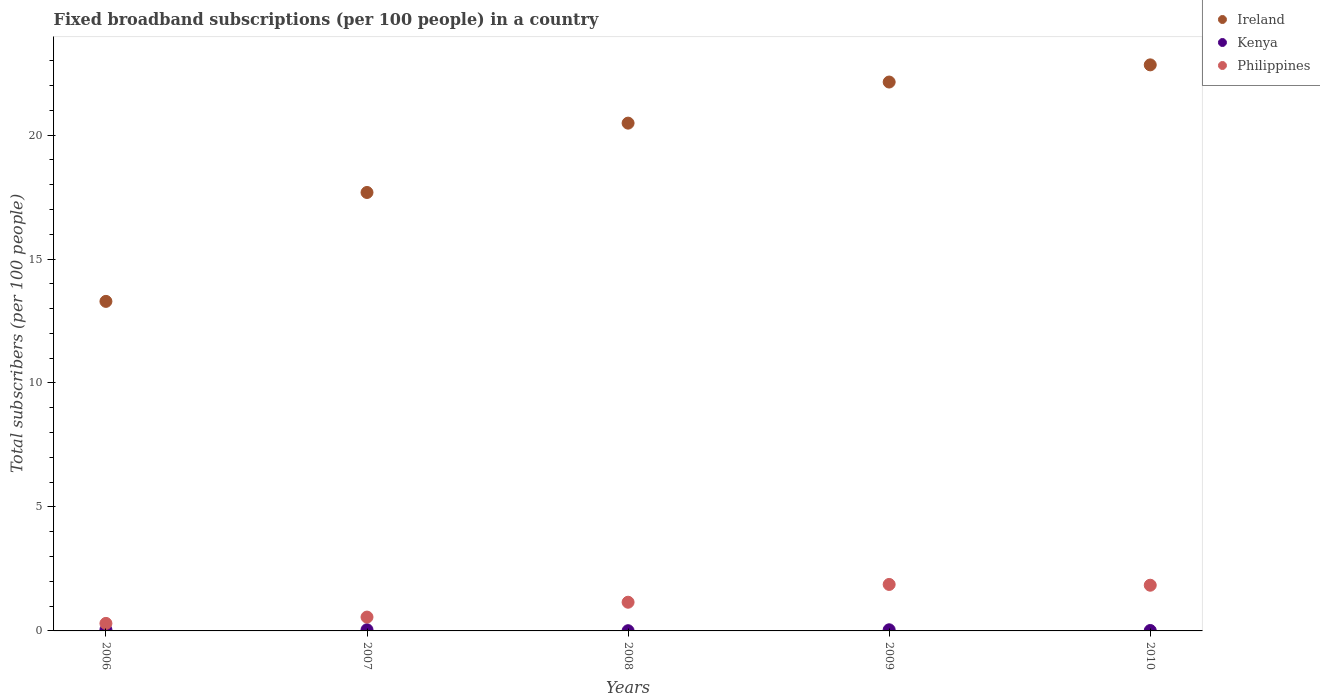How many different coloured dotlines are there?
Your answer should be compact. 3. Is the number of dotlines equal to the number of legend labels?
Provide a succinct answer. Yes. What is the number of broadband subscriptions in Philippines in 2010?
Offer a terse response. 1.84. Across all years, what is the maximum number of broadband subscriptions in Kenya?
Provide a succinct answer. 0.05. Across all years, what is the minimum number of broadband subscriptions in Ireland?
Offer a terse response. 13.29. What is the total number of broadband subscriptions in Kenya in the graph?
Ensure brevity in your answer.  0.17. What is the difference between the number of broadband subscriptions in Ireland in 2006 and that in 2007?
Your answer should be very brief. -4.39. What is the difference between the number of broadband subscriptions in Philippines in 2006 and the number of broadband subscriptions in Kenya in 2007?
Give a very brief answer. 0.26. What is the average number of broadband subscriptions in Kenya per year?
Offer a terse response. 0.03. In the year 2007, what is the difference between the number of broadband subscriptions in Ireland and number of broadband subscriptions in Philippines?
Your answer should be compact. 17.13. In how many years, is the number of broadband subscriptions in Ireland greater than 15?
Offer a very short reply. 4. What is the ratio of the number of broadband subscriptions in Philippines in 2008 to that in 2009?
Give a very brief answer. 0.62. Is the difference between the number of broadband subscriptions in Ireland in 2006 and 2008 greater than the difference between the number of broadband subscriptions in Philippines in 2006 and 2008?
Keep it short and to the point. No. What is the difference between the highest and the second highest number of broadband subscriptions in Kenya?
Offer a terse response. 0. What is the difference between the highest and the lowest number of broadband subscriptions in Ireland?
Your response must be concise. 9.54. In how many years, is the number of broadband subscriptions in Ireland greater than the average number of broadband subscriptions in Ireland taken over all years?
Offer a very short reply. 3. Does the number of broadband subscriptions in Ireland monotonically increase over the years?
Your answer should be compact. Yes. Is the number of broadband subscriptions in Kenya strictly less than the number of broadband subscriptions in Ireland over the years?
Your answer should be very brief. Yes. How many dotlines are there?
Your answer should be compact. 3. Does the graph contain any zero values?
Offer a very short reply. No. How many legend labels are there?
Offer a terse response. 3. What is the title of the graph?
Make the answer very short. Fixed broadband subscriptions (per 100 people) in a country. What is the label or title of the X-axis?
Your answer should be very brief. Years. What is the label or title of the Y-axis?
Provide a succinct answer. Total subscribers (per 100 people). What is the Total subscribers (per 100 people) of Ireland in 2006?
Give a very brief answer. 13.29. What is the Total subscribers (per 100 people) in Kenya in 2006?
Provide a succinct answer. 0.05. What is the Total subscribers (per 100 people) of Philippines in 2006?
Give a very brief answer. 0.3. What is the Total subscribers (per 100 people) of Ireland in 2007?
Provide a short and direct response. 17.68. What is the Total subscribers (per 100 people) of Kenya in 2007?
Your response must be concise. 0.05. What is the Total subscribers (per 100 people) in Philippines in 2007?
Give a very brief answer. 0.56. What is the Total subscribers (per 100 people) in Ireland in 2008?
Keep it short and to the point. 20.48. What is the Total subscribers (per 100 people) in Kenya in 2008?
Keep it short and to the point. 0.01. What is the Total subscribers (per 100 people) of Philippines in 2008?
Offer a very short reply. 1.16. What is the Total subscribers (per 100 people) in Ireland in 2009?
Ensure brevity in your answer.  22.14. What is the Total subscribers (per 100 people) in Kenya in 2009?
Provide a short and direct response. 0.05. What is the Total subscribers (per 100 people) of Philippines in 2009?
Ensure brevity in your answer.  1.87. What is the Total subscribers (per 100 people) of Ireland in 2010?
Make the answer very short. 22.83. What is the Total subscribers (per 100 people) of Kenya in 2010?
Offer a very short reply. 0.02. What is the Total subscribers (per 100 people) in Philippines in 2010?
Keep it short and to the point. 1.84. Across all years, what is the maximum Total subscribers (per 100 people) of Ireland?
Offer a terse response. 22.83. Across all years, what is the maximum Total subscribers (per 100 people) of Kenya?
Provide a short and direct response. 0.05. Across all years, what is the maximum Total subscribers (per 100 people) of Philippines?
Offer a very short reply. 1.87. Across all years, what is the minimum Total subscribers (per 100 people) of Ireland?
Provide a short and direct response. 13.29. Across all years, what is the minimum Total subscribers (per 100 people) of Kenya?
Keep it short and to the point. 0.01. Across all years, what is the minimum Total subscribers (per 100 people) of Philippines?
Offer a very short reply. 0.3. What is the total Total subscribers (per 100 people) of Ireland in the graph?
Make the answer very short. 96.42. What is the total Total subscribers (per 100 people) of Kenya in the graph?
Offer a very short reply. 0.17. What is the total Total subscribers (per 100 people) of Philippines in the graph?
Provide a short and direct response. 5.74. What is the difference between the Total subscribers (per 100 people) in Ireland in 2006 and that in 2007?
Your answer should be compact. -4.39. What is the difference between the Total subscribers (per 100 people) of Kenya in 2006 and that in 2007?
Provide a succinct answer. 0. What is the difference between the Total subscribers (per 100 people) of Philippines in 2006 and that in 2007?
Offer a terse response. -0.25. What is the difference between the Total subscribers (per 100 people) in Ireland in 2006 and that in 2008?
Your response must be concise. -7.19. What is the difference between the Total subscribers (per 100 people) in Kenya in 2006 and that in 2008?
Offer a very short reply. 0.04. What is the difference between the Total subscribers (per 100 people) in Philippines in 2006 and that in 2008?
Ensure brevity in your answer.  -0.85. What is the difference between the Total subscribers (per 100 people) in Ireland in 2006 and that in 2009?
Offer a very short reply. -8.85. What is the difference between the Total subscribers (per 100 people) in Kenya in 2006 and that in 2009?
Provide a short and direct response. 0. What is the difference between the Total subscribers (per 100 people) of Philippines in 2006 and that in 2009?
Your answer should be very brief. -1.57. What is the difference between the Total subscribers (per 100 people) of Ireland in 2006 and that in 2010?
Your answer should be very brief. -9.54. What is the difference between the Total subscribers (per 100 people) of Kenya in 2006 and that in 2010?
Your answer should be very brief. 0.03. What is the difference between the Total subscribers (per 100 people) of Philippines in 2006 and that in 2010?
Your answer should be very brief. -1.54. What is the difference between the Total subscribers (per 100 people) in Ireland in 2007 and that in 2008?
Your response must be concise. -2.8. What is the difference between the Total subscribers (per 100 people) in Kenya in 2007 and that in 2008?
Make the answer very short. 0.04. What is the difference between the Total subscribers (per 100 people) in Philippines in 2007 and that in 2008?
Offer a very short reply. -0.6. What is the difference between the Total subscribers (per 100 people) of Ireland in 2007 and that in 2009?
Give a very brief answer. -4.45. What is the difference between the Total subscribers (per 100 people) in Kenya in 2007 and that in 2009?
Your answer should be very brief. 0. What is the difference between the Total subscribers (per 100 people) of Philippines in 2007 and that in 2009?
Your answer should be very brief. -1.32. What is the difference between the Total subscribers (per 100 people) in Ireland in 2007 and that in 2010?
Your answer should be compact. -5.15. What is the difference between the Total subscribers (per 100 people) in Kenya in 2007 and that in 2010?
Provide a short and direct response. 0.03. What is the difference between the Total subscribers (per 100 people) of Philippines in 2007 and that in 2010?
Give a very brief answer. -1.28. What is the difference between the Total subscribers (per 100 people) in Ireland in 2008 and that in 2009?
Provide a succinct answer. -1.66. What is the difference between the Total subscribers (per 100 people) in Kenya in 2008 and that in 2009?
Keep it short and to the point. -0.04. What is the difference between the Total subscribers (per 100 people) in Philippines in 2008 and that in 2009?
Keep it short and to the point. -0.72. What is the difference between the Total subscribers (per 100 people) in Ireland in 2008 and that in 2010?
Make the answer very short. -2.35. What is the difference between the Total subscribers (per 100 people) in Kenya in 2008 and that in 2010?
Your answer should be very brief. -0.01. What is the difference between the Total subscribers (per 100 people) of Philippines in 2008 and that in 2010?
Offer a very short reply. -0.69. What is the difference between the Total subscribers (per 100 people) in Ireland in 2009 and that in 2010?
Keep it short and to the point. -0.69. What is the difference between the Total subscribers (per 100 people) in Kenya in 2009 and that in 2010?
Offer a terse response. 0.03. What is the difference between the Total subscribers (per 100 people) in Philippines in 2009 and that in 2010?
Offer a very short reply. 0.03. What is the difference between the Total subscribers (per 100 people) of Ireland in 2006 and the Total subscribers (per 100 people) of Kenya in 2007?
Offer a terse response. 13.24. What is the difference between the Total subscribers (per 100 people) of Ireland in 2006 and the Total subscribers (per 100 people) of Philippines in 2007?
Provide a succinct answer. 12.73. What is the difference between the Total subscribers (per 100 people) in Kenya in 2006 and the Total subscribers (per 100 people) in Philippines in 2007?
Offer a terse response. -0.51. What is the difference between the Total subscribers (per 100 people) in Ireland in 2006 and the Total subscribers (per 100 people) in Kenya in 2008?
Your answer should be compact. 13.28. What is the difference between the Total subscribers (per 100 people) of Ireland in 2006 and the Total subscribers (per 100 people) of Philippines in 2008?
Ensure brevity in your answer.  12.13. What is the difference between the Total subscribers (per 100 people) in Kenya in 2006 and the Total subscribers (per 100 people) in Philippines in 2008?
Your answer should be very brief. -1.11. What is the difference between the Total subscribers (per 100 people) in Ireland in 2006 and the Total subscribers (per 100 people) in Kenya in 2009?
Keep it short and to the point. 13.25. What is the difference between the Total subscribers (per 100 people) of Ireland in 2006 and the Total subscribers (per 100 people) of Philippines in 2009?
Your response must be concise. 11.42. What is the difference between the Total subscribers (per 100 people) of Kenya in 2006 and the Total subscribers (per 100 people) of Philippines in 2009?
Make the answer very short. -1.83. What is the difference between the Total subscribers (per 100 people) in Ireland in 2006 and the Total subscribers (per 100 people) in Kenya in 2010?
Make the answer very short. 13.27. What is the difference between the Total subscribers (per 100 people) of Ireland in 2006 and the Total subscribers (per 100 people) of Philippines in 2010?
Keep it short and to the point. 11.45. What is the difference between the Total subscribers (per 100 people) of Kenya in 2006 and the Total subscribers (per 100 people) of Philippines in 2010?
Make the answer very short. -1.79. What is the difference between the Total subscribers (per 100 people) in Ireland in 2007 and the Total subscribers (per 100 people) in Kenya in 2008?
Your response must be concise. 17.68. What is the difference between the Total subscribers (per 100 people) in Ireland in 2007 and the Total subscribers (per 100 people) in Philippines in 2008?
Give a very brief answer. 16.53. What is the difference between the Total subscribers (per 100 people) of Kenya in 2007 and the Total subscribers (per 100 people) of Philippines in 2008?
Provide a short and direct response. -1.11. What is the difference between the Total subscribers (per 100 people) in Ireland in 2007 and the Total subscribers (per 100 people) in Kenya in 2009?
Ensure brevity in your answer.  17.64. What is the difference between the Total subscribers (per 100 people) of Ireland in 2007 and the Total subscribers (per 100 people) of Philippines in 2009?
Your response must be concise. 15.81. What is the difference between the Total subscribers (per 100 people) of Kenya in 2007 and the Total subscribers (per 100 people) of Philippines in 2009?
Offer a very short reply. -1.83. What is the difference between the Total subscribers (per 100 people) in Ireland in 2007 and the Total subscribers (per 100 people) in Kenya in 2010?
Offer a terse response. 17.67. What is the difference between the Total subscribers (per 100 people) of Ireland in 2007 and the Total subscribers (per 100 people) of Philippines in 2010?
Offer a terse response. 15.84. What is the difference between the Total subscribers (per 100 people) in Kenya in 2007 and the Total subscribers (per 100 people) in Philippines in 2010?
Offer a terse response. -1.8. What is the difference between the Total subscribers (per 100 people) in Ireland in 2008 and the Total subscribers (per 100 people) in Kenya in 2009?
Provide a short and direct response. 20.43. What is the difference between the Total subscribers (per 100 people) in Ireland in 2008 and the Total subscribers (per 100 people) in Philippines in 2009?
Provide a short and direct response. 18.61. What is the difference between the Total subscribers (per 100 people) in Kenya in 2008 and the Total subscribers (per 100 people) in Philippines in 2009?
Your answer should be compact. -1.87. What is the difference between the Total subscribers (per 100 people) of Ireland in 2008 and the Total subscribers (per 100 people) of Kenya in 2010?
Ensure brevity in your answer.  20.46. What is the difference between the Total subscribers (per 100 people) in Ireland in 2008 and the Total subscribers (per 100 people) in Philippines in 2010?
Provide a succinct answer. 18.64. What is the difference between the Total subscribers (per 100 people) of Kenya in 2008 and the Total subscribers (per 100 people) of Philippines in 2010?
Give a very brief answer. -1.83. What is the difference between the Total subscribers (per 100 people) in Ireland in 2009 and the Total subscribers (per 100 people) in Kenya in 2010?
Make the answer very short. 22.12. What is the difference between the Total subscribers (per 100 people) of Ireland in 2009 and the Total subscribers (per 100 people) of Philippines in 2010?
Make the answer very short. 20.29. What is the difference between the Total subscribers (per 100 people) of Kenya in 2009 and the Total subscribers (per 100 people) of Philippines in 2010?
Your response must be concise. -1.8. What is the average Total subscribers (per 100 people) in Ireland per year?
Your answer should be very brief. 19.28. What is the average Total subscribers (per 100 people) in Kenya per year?
Your response must be concise. 0.03. What is the average Total subscribers (per 100 people) of Philippines per year?
Your answer should be compact. 1.15. In the year 2006, what is the difference between the Total subscribers (per 100 people) in Ireland and Total subscribers (per 100 people) in Kenya?
Keep it short and to the point. 13.24. In the year 2006, what is the difference between the Total subscribers (per 100 people) of Ireland and Total subscribers (per 100 people) of Philippines?
Your response must be concise. 12.99. In the year 2006, what is the difference between the Total subscribers (per 100 people) of Kenya and Total subscribers (per 100 people) of Philippines?
Give a very brief answer. -0.26. In the year 2007, what is the difference between the Total subscribers (per 100 people) in Ireland and Total subscribers (per 100 people) in Kenya?
Keep it short and to the point. 17.64. In the year 2007, what is the difference between the Total subscribers (per 100 people) of Ireland and Total subscribers (per 100 people) of Philippines?
Provide a short and direct response. 17.13. In the year 2007, what is the difference between the Total subscribers (per 100 people) of Kenya and Total subscribers (per 100 people) of Philippines?
Keep it short and to the point. -0.51. In the year 2008, what is the difference between the Total subscribers (per 100 people) in Ireland and Total subscribers (per 100 people) in Kenya?
Provide a short and direct response. 20.47. In the year 2008, what is the difference between the Total subscribers (per 100 people) of Ireland and Total subscribers (per 100 people) of Philippines?
Provide a succinct answer. 19.32. In the year 2008, what is the difference between the Total subscribers (per 100 people) of Kenya and Total subscribers (per 100 people) of Philippines?
Give a very brief answer. -1.15. In the year 2009, what is the difference between the Total subscribers (per 100 people) of Ireland and Total subscribers (per 100 people) of Kenya?
Give a very brief answer. 22.09. In the year 2009, what is the difference between the Total subscribers (per 100 people) in Ireland and Total subscribers (per 100 people) in Philippines?
Provide a succinct answer. 20.26. In the year 2009, what is the difference between the Total subscribers (per 100 people) in Kenya and Total subscribers (per 100 people) in Philippines?
Provide a succinct answer. -1.83. In the year 2010, what is the difference between the Total subscribers (per 100 people) in Ireland and Total subscribers (per 100 people) in Kenya?
Offer a terse response. 22.81. In the year 2010, what is the difference between the Total subscribers (per 100 people) in Ireland and Total subscribers (per 100 people) in Philippines?
Offer a terse response. 20.99. In the year 2010, what is the difference between the Total subscribers (per 100 people) of Kenya and Total subscribers (per 100 people) of Philippines?
Your answer should be compact. -1.83. What is the ratio of the Total subscribers (per 100 people) in Ireland in 2006 to that in 2007?
Your answer should be compact. 0.75. What is the ratio of the Total subscribers (per 100 people) in Kenya in 2006 to that in 2007?
Your answer should be very brief. 1.03. What is the ratio of the Total subscribers (per 100 people) in Philippines in 2006 to that in 2007?
Provide a short and direct response. 0.54. What is the ratio of the Total subscribers (per 100 people) in Ireland in 2006 to that in 2008?
Offer a very short reply. 0.65. What is the ratio of the Total subscribers (per 100 people) in Kenya in 2006 to that in 2008?
Your response must be concise. 5.7. What is the ratio of the Total subscribers (per 100 people) of Philippines in 2006 to that in 2008?
Your response must be concise. 0.26. What is the ratio of the Total subscribers (per 100 people) of Ireland in 2006 to that in 2009?
Offer a very short reply. 0.6. What is the ratio of the Total subscribers (per 100 people) in Kenya in 2006 to that in 2009?
Your answer should be very brief. 1.05. What is the ratio of the Total subscribers (per 100 people) in Philippines in 2006 to that in 2009?
Your answer should be compact. 0.16. What is the ratio of the Total subscribers (per 100 people) of Ireland in 2006 to that in 2010?
Your response must be concise. 0.58. What is the ratio of the Total subscribers (per 100 people) in Kenya in 2006 to that in 2010?
Make the answer very short. 2.87. What is the ratio of the Total subscribers (per 100 people) of Philippines in 2006 to that in 2010?
Offer a very short reply. 0.16. What is the ratio of the Total subscribers (per 100 people) in Ireland in 2007 to that in 2008?
Ensure brevity in your answer.  0.86. What is the ratio of the Total subscribers (per 100 people) of Kenya in 2007 to that in 2008?
Offer a terse response. 5.55. What is the ratio of the Total subscribers (per 100 people) of Philippines in 2007 to that in 2008?
Keep it short and to the point. 0.48. What is the ratio of the Total subscribers (per 100 people) of Ireland in 2007 to that in 2009?
Your answer should be compact. 0.8. What is the ratio of the Total subscribers (per 100 people) of Kenya in 2007 to that in 2009?
Give a very brief answer. 1.03. What is the ratio of the Total subscribers (per 100 people) of Philippines in 2007 to that in 2009?
Provide a succinct answer. 0.3. What is the ratio of the Total subscribers (per 100 people) in Ireland in 2007 to that in 2010?
Give a very brief answer. 0.77. What is the ratio of the Total subscribers (per 100 people) of Kenya in 2007 to that in 2010?
Give a very brief answer. 2.8. What is the ratio of the Total subscribers (per 100 people) in Philippines in 2007 to that in 2010?
Your answer should be very brief. 0.3. What is the ratio of the Total subscribers (per 100 people) in Ireland in 2008 to that in 2009?
Your answer should be compact. 0.93. What is the ratio of the Total subscribers (per 100 people) in Kenya in 2008 to that in 2009?
Provide a short and direct response. 0.19. What is the ratio of the Total subscribers (per 100 people) in Philippines in 2008 to that in 2009?
Offer a terse response. 0.62. What is the ratio of the Total subscribers (per 100 people) in Ireland in 2008 to that in 2010?
Provide a succinct answer. 0.9. What is the ratio of the Total subscribers (per 100 people) of Kenya in 2008 to that in 2010?
Offer a terse response. 0.5. What is the ratio of the Total subscribers (per 100 people) in Philippines in 2008 to that in 2010?
Your answer should be compact. 0.63. What is the ratio of the Total subscribers (per 100 people) of Ireland in 2009 to that in 2010?
Provide a succinct answer. 0.97. What is the ratio of the Total subscribers (per 100 people) in Kenya in 2009 to that in 2010?
Provide a short and direct response. 2.72. What is the ratio of the Total subscribers (per 100 people) in Philippines in 2009 to that in 2010?
Offer a very short reply. 1.02. What is the difference between the highest and the second highest Total subscribers (per 100 people) in Ireland?
Offer a very short reply. 0.69. What is the difference between the highest and the second highest Total subscribers (per 100 people) of Kenya?
Offer a terse response. 0. What is the difference between the highest and the second highest Total subscribers (per 100 people) in Philippines?
Offer a terse response. 0.03. What is the difference between the highest and the lowest Total subscribers (per 100 people) of Ireland?
Give a very brief answer. 9.54. What is the difference between the highest and the lowest Total subscribers (per 100 people) in Kenya?
Keep it short and to the point. 0.04. What is the difference between the highest and the lowest Total subscribers (per 100 people) of Philippines?
Offer a terse response. 1.57. 